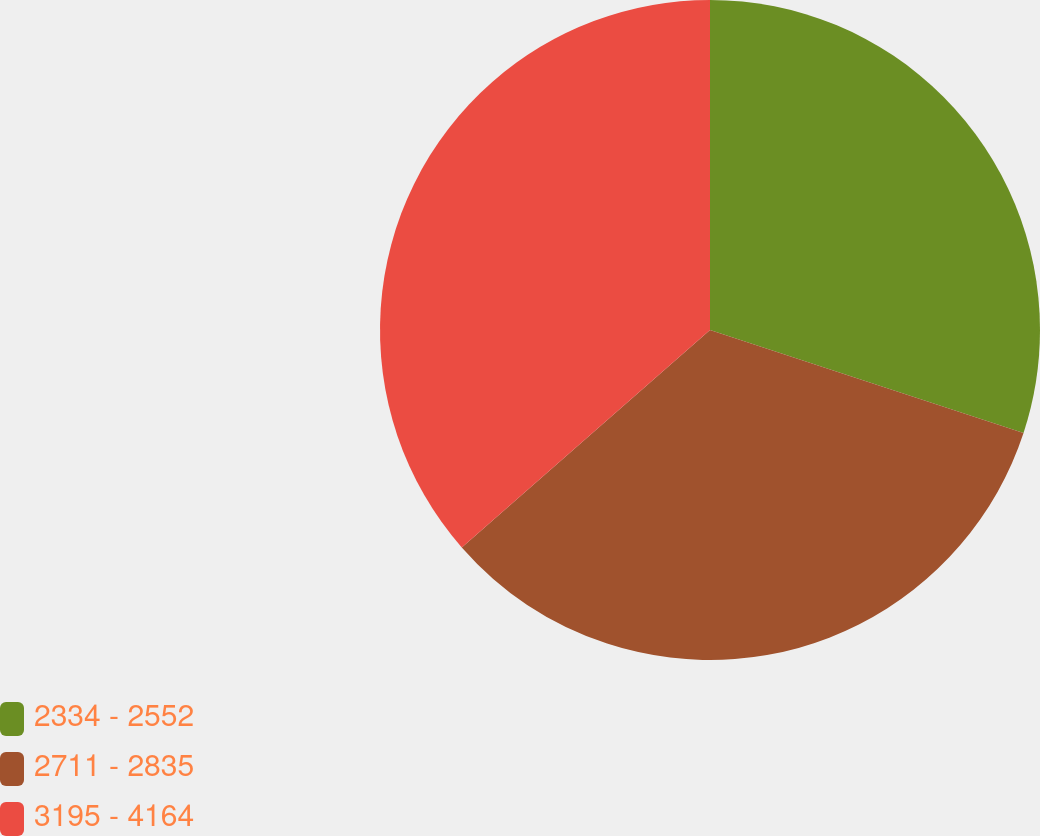Convert chart. <chart><loc_0><loc_0><loc_500><loc_500><pie_chart><fcel>2334 - 2552<fcel>2711 - 2835<fcel>3195 - 4164<nl><fcel>30.05%<fcel>33.5%<fcel>36.45%<nl></chart> 